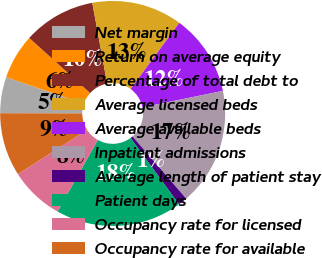Convert chart. <chart><loc_0><loc_0><loc_500><loc_500><pie_chart><fcel>Net margin<fcel>Return on average equity<fcel>Percentage of total debt to<fcel>Average licensed beds<fcel>Average available beds<fcel>Inpatient admissions<fcel>Average length of patient stay<fcel>Patient days<fcel>Occupancy rate for licensed<fcel>Occupancy rate for available<nl><fcel>5.19%<fcel>6.49%<fcel>10.39%<fcel>12.99%<fcel>11.69%<fcel>16.88%<fcel>1.3%<fcel>18.18%<fcel>7.79%<fcel>9.09%<nl></chart> 